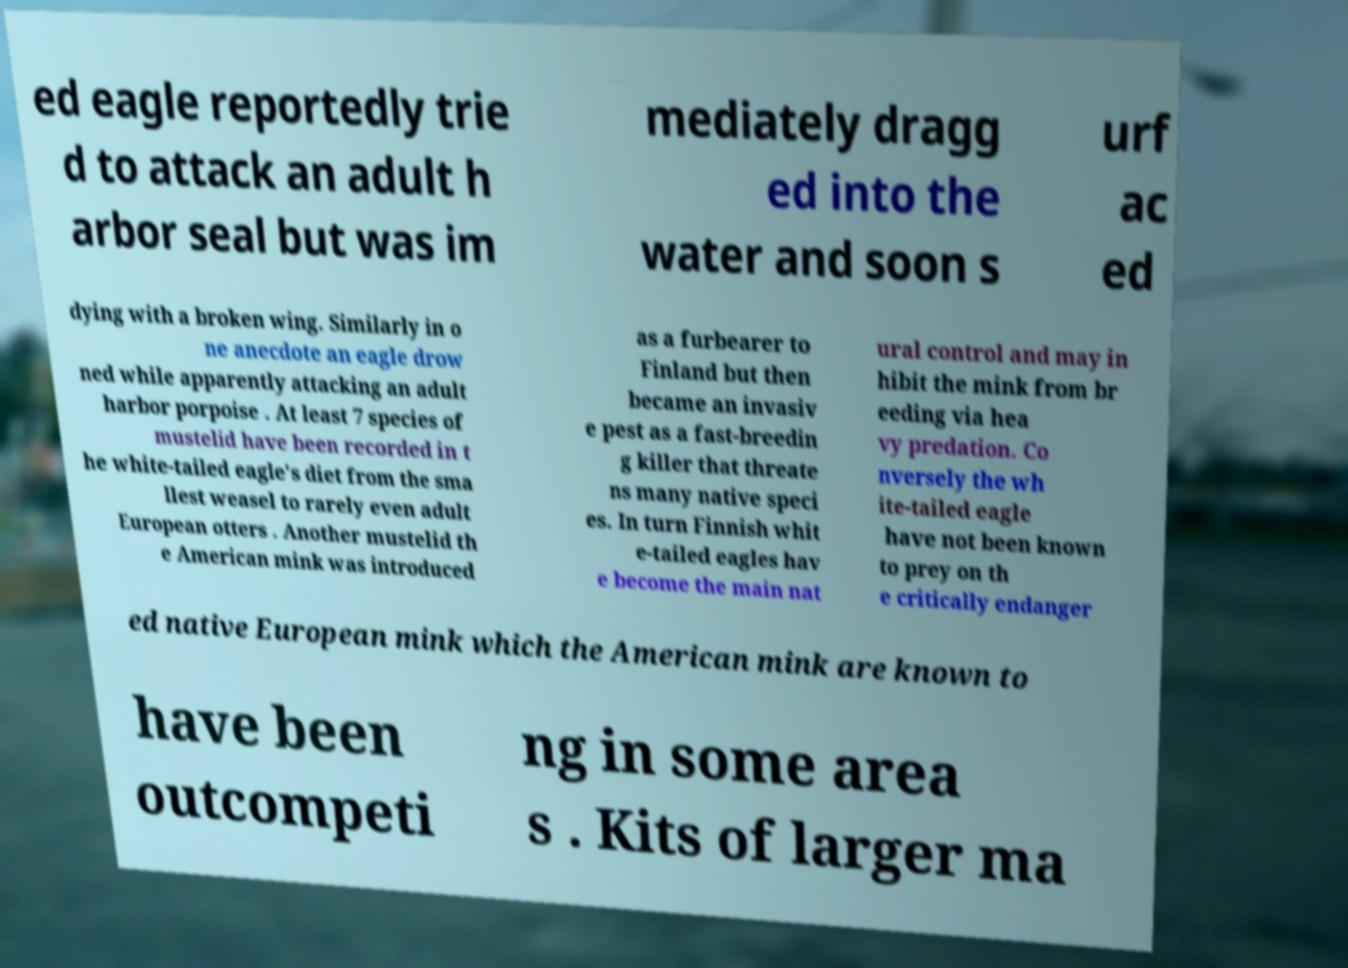Please identify and transcribe the text found in this image. ed eagle reportedly trie d to attack an adult h arbor seal but was im mediately dragg ed into the water and soon s urf ac ed dying with a broken wing. Similarly in o ne anecdote an eagle drow ned while apparently attacking an adult harbor porpoise . At least 7 species of mustelid have been recorded in t he white-tailed eagle's diet from the sma llest weasel to rarely even adult European otters . Another mustelid th e American mink was introduced as a furbearer to Finland but then became an invasiv e pest as a fast-breedin g killer that threate ns many native speci es. In turn Finnish whit e-tailed eagles hav e become the main nat ural control and may in hibit the mink from br eeding via hea vy predation. Co nversely the wh ite-tailed eagle have not been known to prey on th e critically endanger ed native European mink which the American mink are known to have been outcompeti ng in some area s . Kits of larger ma 